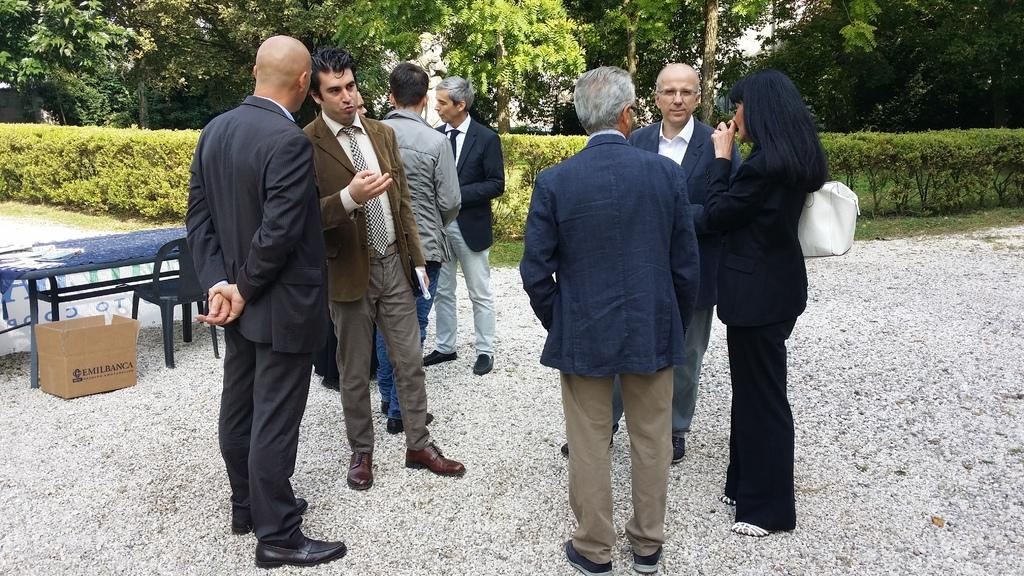How many people can be seen in the image? There are many people standing in the image. What is located near the people in the image? There is a table in the image. What object is near the table in the image? There is a cardboard box near the table. What piece of furniture is also near the table in the image? There is a chair near the table. What can be seen in the background of the image? There are bushes and trees in the background of the image. How many cars can be seen driving through the bushes in the image? There are no cars visible in the image; only people, a table, a cardboard box, a chair, bushes, and trees can be seen. 